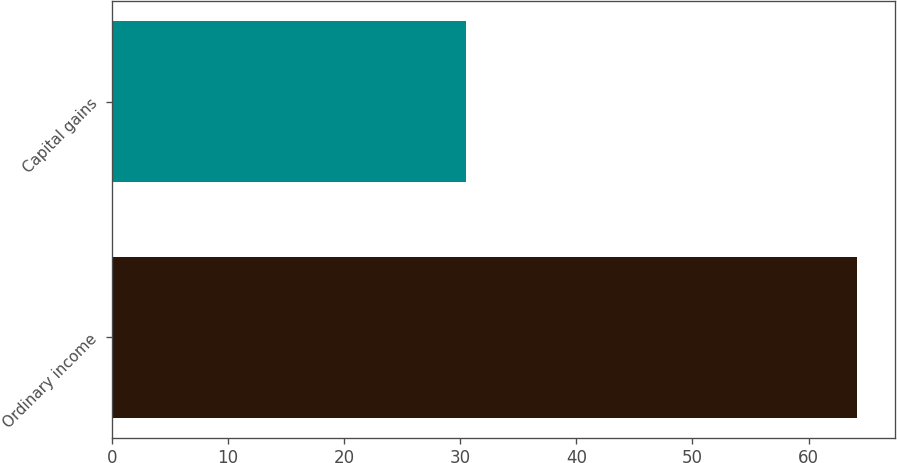<chart> <loc_0><loc_0><loc_500><loc_500><bar_chart><fcel>Ordinary income<fcel>Capital gains<nl><fcel>64.2<fcel>30.5<nl></chart> 